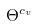Convert formula to latex. <formula><loc_0><loc_0><loc_500><loc_500>\Theta ^ { c _ { v } }</formula> 